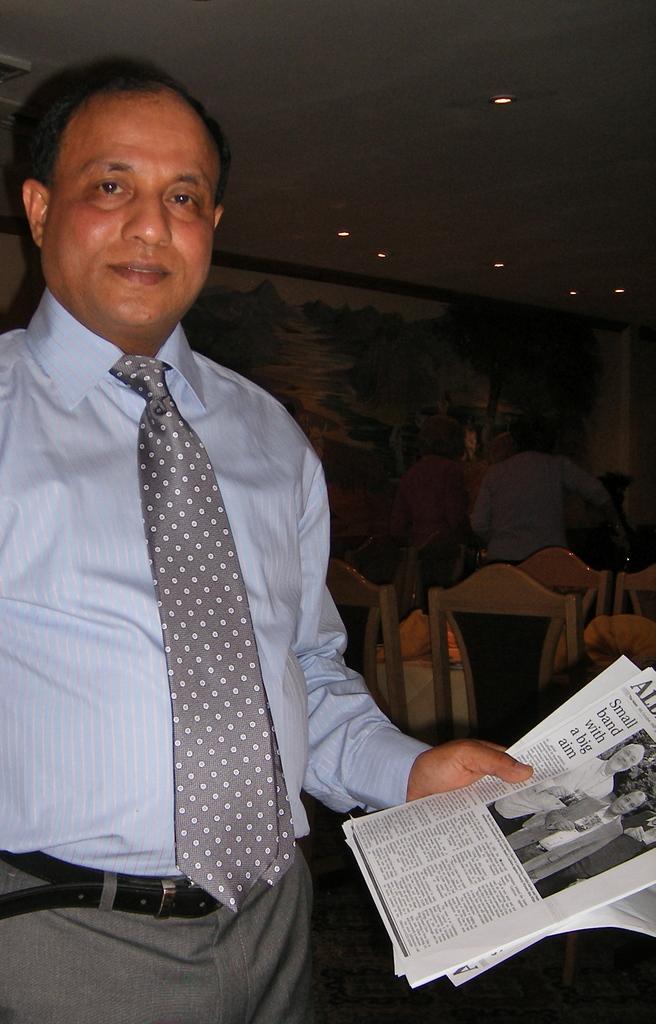How would you summarize this image in a sentence or two? In this picture, we can see a few people, and among them a person is holding some posters with text and images on it, we can see chairs, wall, and the roof with lights. 